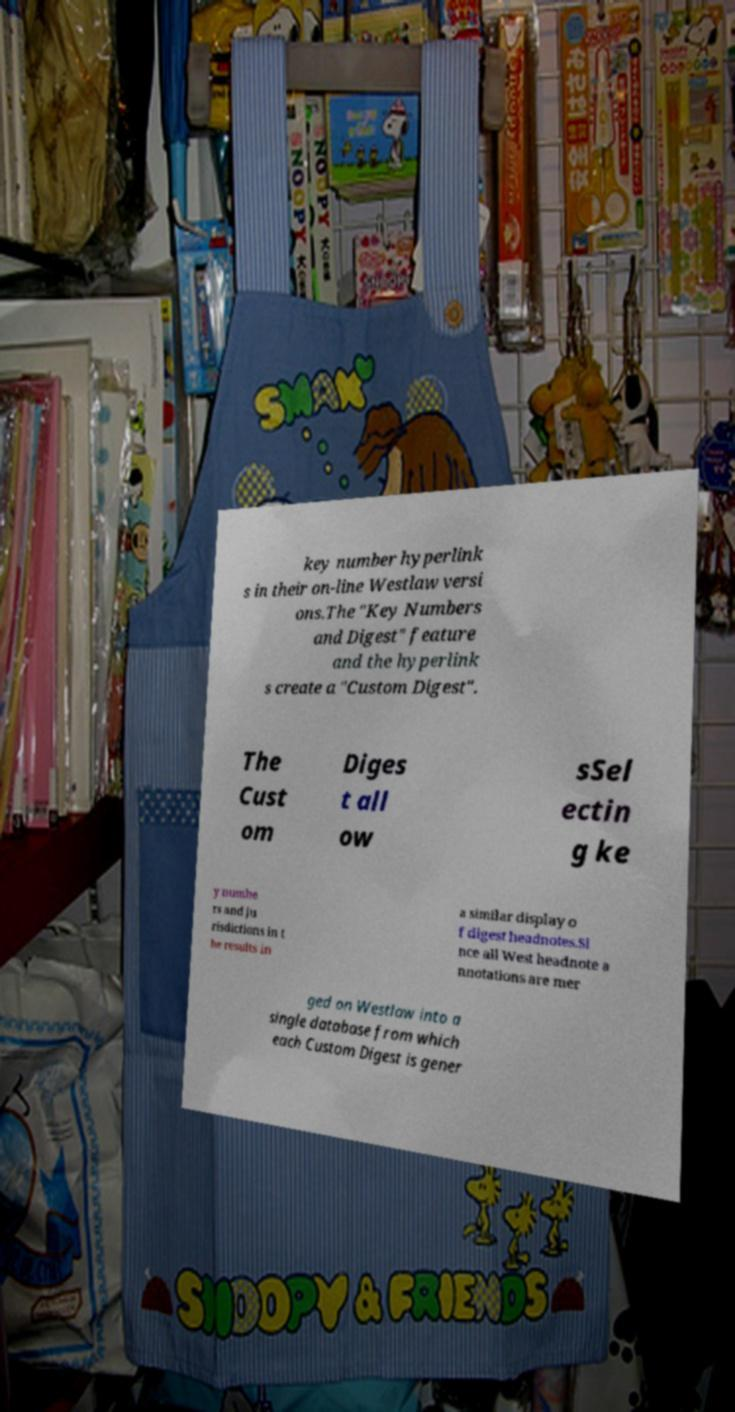I need the written content from this picture converted into text. Can you do that? key number hyperlink s in their on-line Westlaw versi ons.The "Key Numbers and Digest" feature and the hyperlink s create a "Custom Digest". The Cust om Diges t all ow sSel ectin g ke y numbe rs and ju risdictions in t he results in a similar display o f digest headnotes.Si nce all West headnote a nnotations are mer ged on Westlaw into a single database from which each Custom Digest is gener 